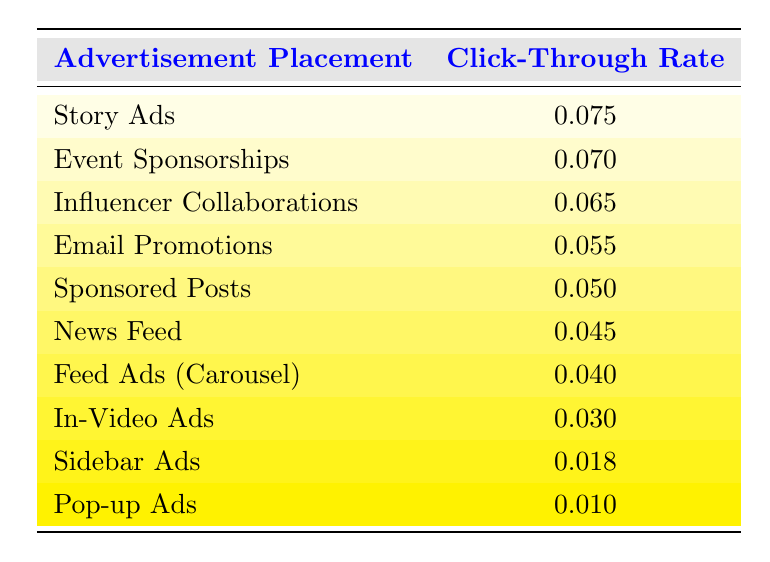What is the click-through rate for Story Ads? The table lists the click-through rate for Story Ads as 0.075.
Answer: 0.075 Which advertisement placement has the lowest click-through rate? According to the table, Pop-up Ads have the lowest click-through rate at 0.010.
Answer: 0.010 What is the average click-through rate for the top three advertisement placements? The top three placements are Story Ads (0.075), Event Sponsorships (0.070), and Influencer Collaborations (0.065). Their sum is 0.075 + 0.070 + 0.065 = 0.210, and then 0.210 divided by 3 gives an average of 0.070.
Answer: 0.070 Is the click-through rate for Sponsored Posts greater than that for In-Video Ads? Sponsored Posts have a click-through rate of 0.050, while In-Video Ads have 0.030. Since 0.050 is greater than 0.030, the statement is true.
Answer: Yes How many advertisement placements have a click-through rate greater than 0.050? The placements with rates greater than 0.050 are: Story Ads (0.075), Event Sponsorships (0.070), Influencer Collaborations (0.065), and Email Promotions (0.055). This counts to four placements.
Answer: 4 